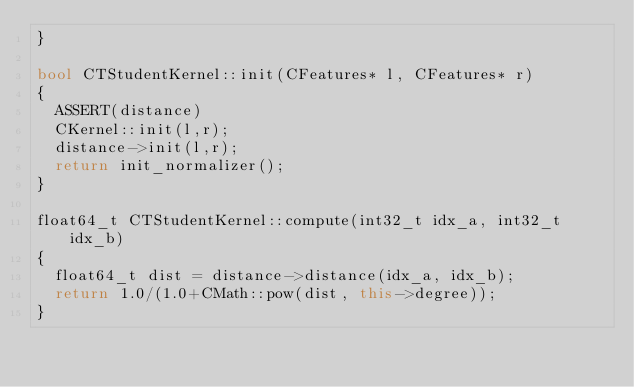Convert code to text. <code><loc_0><loc_0><loc_500><loc_500><_C++_>}

bool CTStudentKernel::init(CFeatures* l, CFeatures* r)
{
	ASSERT(distance)
	CKernel::init(l,r);
	distance->init(l,r);
	return init_normalizer();
}

float64_t CTStudentKernel::compute(int32_t idx_a, int32_t idx_b)
{
	float64_t dist = distance->distance(idx_a, idx_b);
	return 1.0/(1.0+CMath::pow(dist, this->degree));
}
</code> 